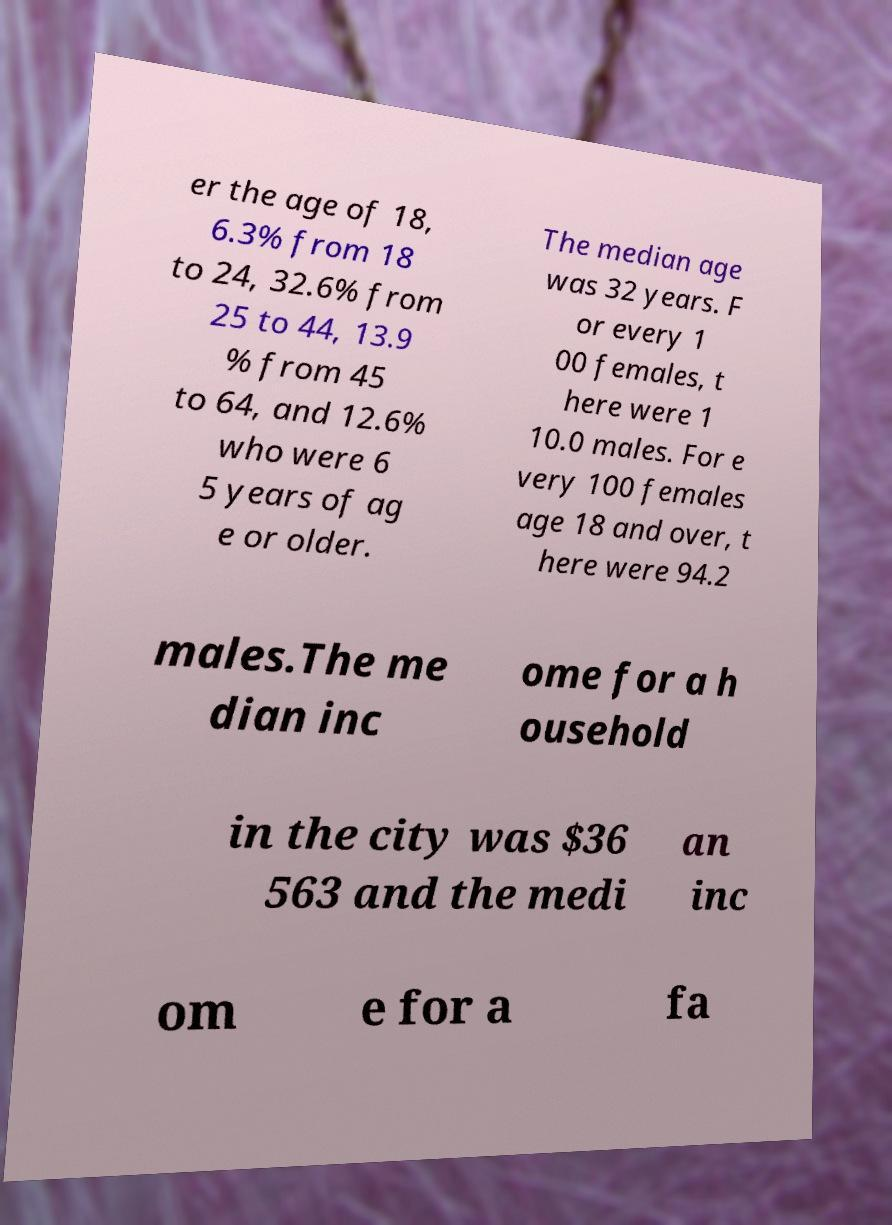Please read and relay the text visible in this image. What does it say? er the age of 18, 6.3% from 18 to 24, 32.6% from 25 to 44, 13.9 % from 45 to 64, and 12.6% who were 6 5 years of ag e or older. The median age was 32 years. F or every 1 00 females, t here were 1 10.0 males. For e very 100 females age 18 and over, t here were 94.2 males.The me dian inc ome for a h ousehold in the city was $36 563 and the medi an inc om e for a fa 